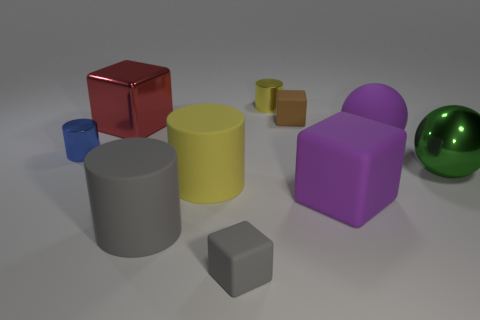Subtract 1 cylinders. How many cylinders are left? 3 Subtract all balls. How many objects are left? 8 Subtract all large purple spheres. Subtract all tiny gray things. How many objects are left? 8 Add 3 red metal blocks. How many red metal blocks are left? 4 Add 3 small blue cylinders. How many small blue cylinders exist? 4 Subtract 0 blue blocks. How many objects are left? 10 